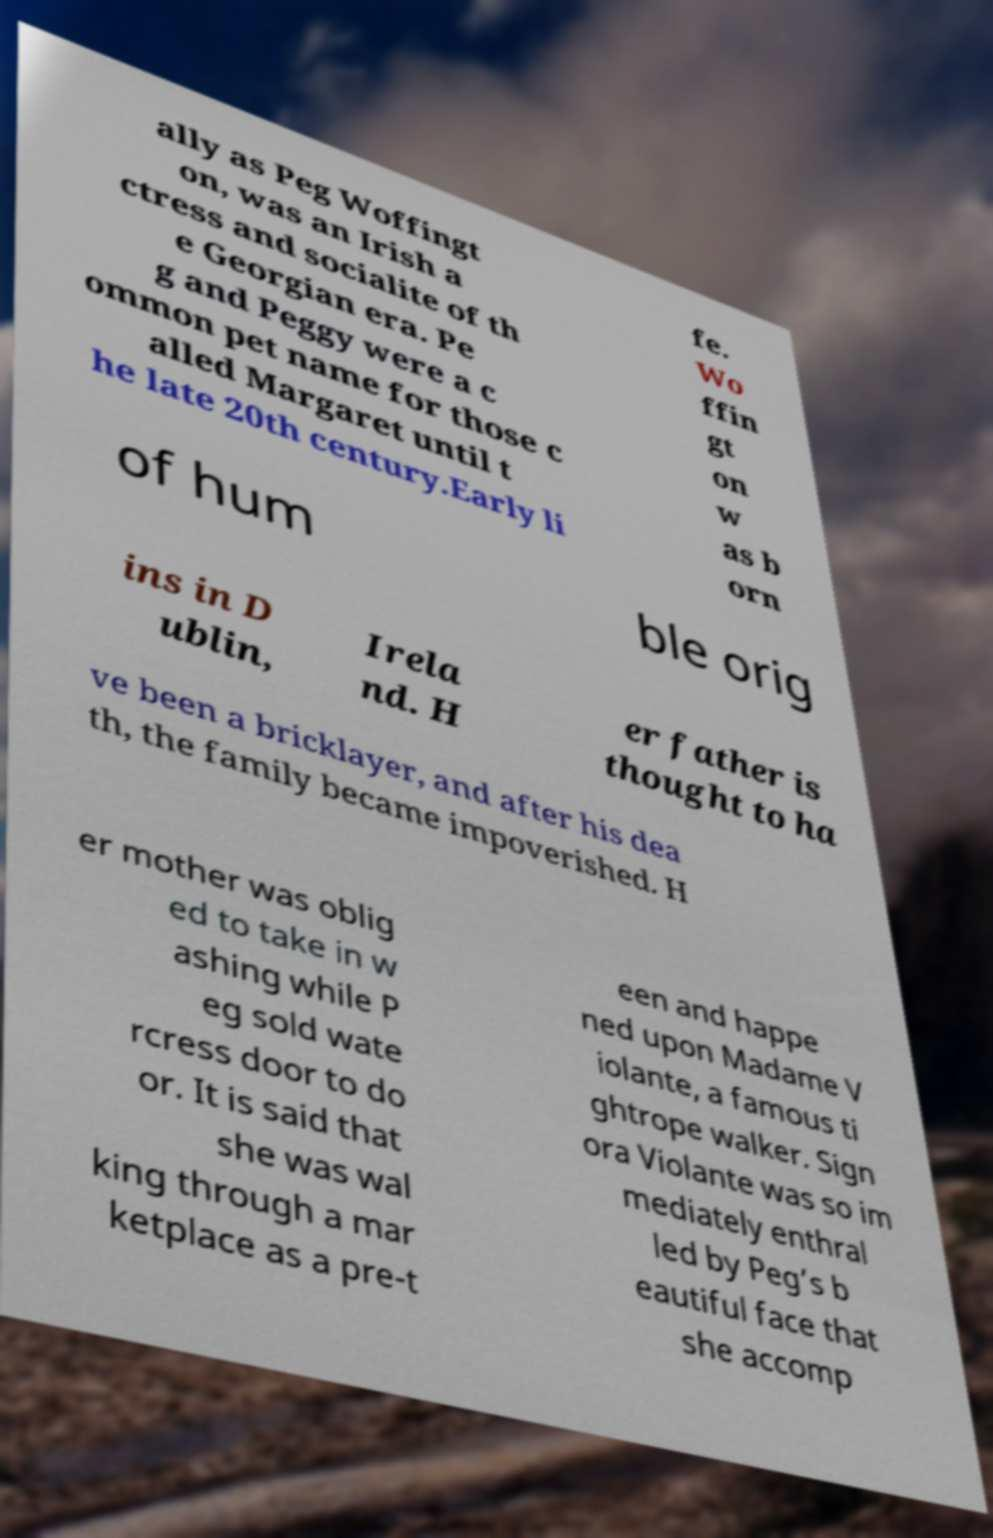There's text embedded in this image that I need extracted. Can you transcribe it verbatim? ally as Peg Woffingt on, was an Irish a ctress and socialite of th e Georgian era. Pe g and Peggy were a c ommon pet name for those c alled Margaret until t he late 20th century.Early li fe. Wo ffin gt on w as b orn of hum ble orig ins in D ublin, Irela nd. H er father is thought to ha ve been a bricklayer, and after his dea th, the family became impoverished. H er mother was oblig ed to take in w ashing while P eg sold wate rcress door to do or. It is said that she was wal king through a mar ketplace as a pre-t een and happe ned upon Madame V iolante, a famous ti ghtrope walker. Sign ora Violante was so im mediately enthral led by Peg’s b eautiful face that she accomp 